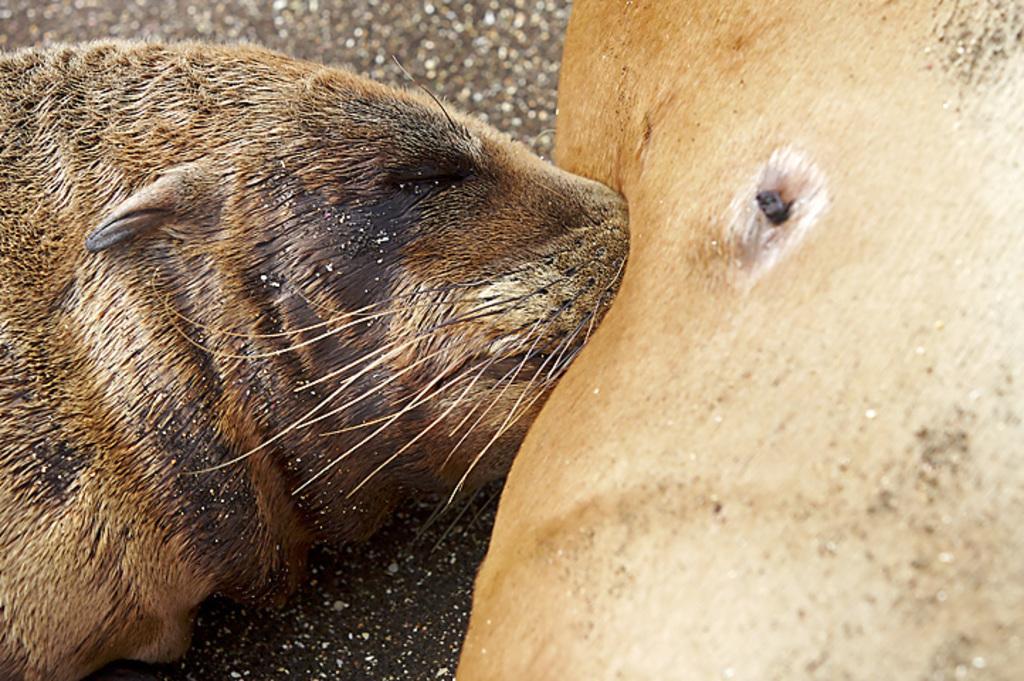In one or two sentences, can you explain what this image depicts? In this picture there is a seal lying on the floor. 